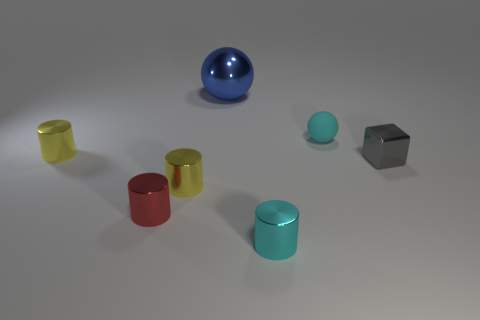Subtract 2 cylinders. How many cylinders are left? 2 Add 3 metal cylinders. How many objects exist? 10 Subtract all brown cylinders. Subtract all yellow spheres. How many cylinders are left? 4 Subtract all balls. How many objects are left? 5 Subtract 1 cyan cylinders. How many objects are left? 6 Subtract all cyan matte blocks. Subtract all yellow cylinders. How many objects are left? 5 Add 5 tiny red metal objects. How many tiny red metal objects are left? 6 Add 2 red metallic cubes. How many red metallic cubes exist? 2 